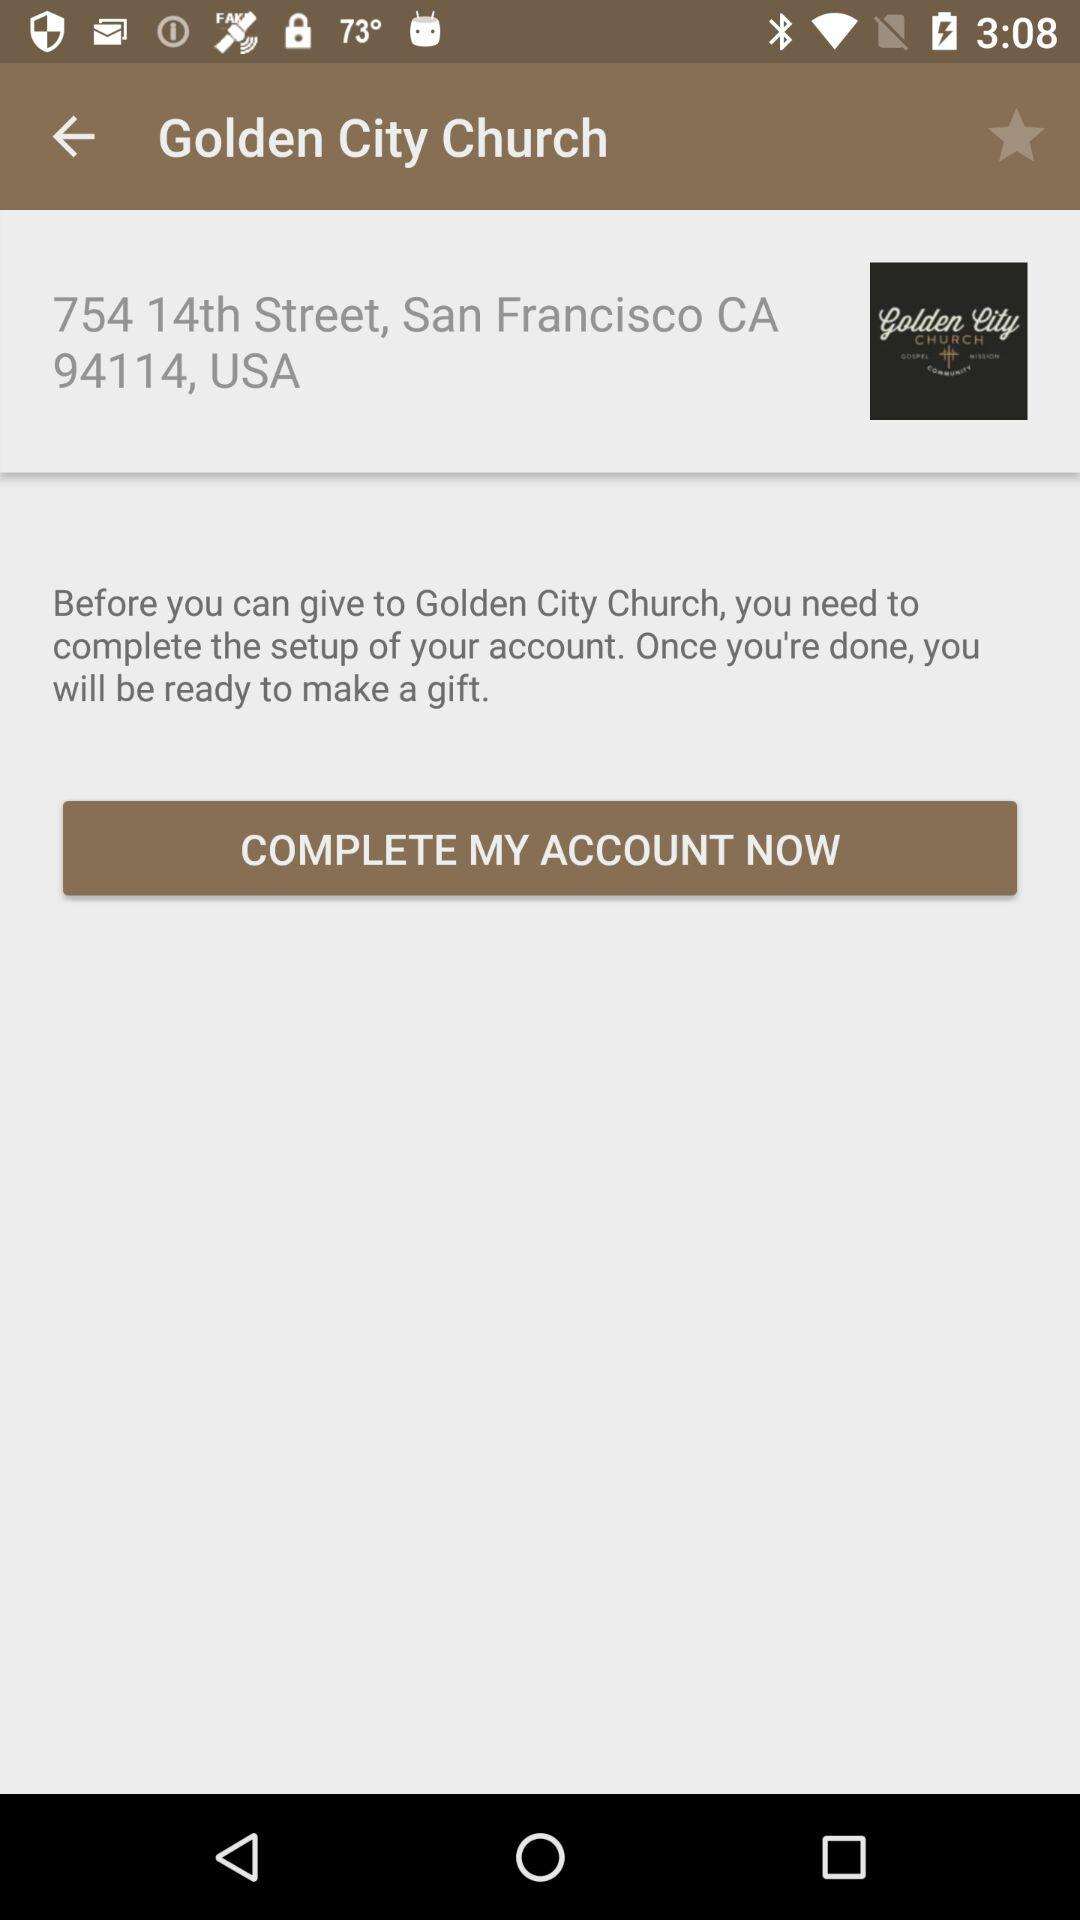What is the PIN code? The PIN code is 94114. 